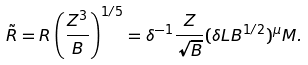Convert formula to latex. <formula><loc_0><loc_0><loc_500><loc_500>\tilde { R } = R \left ( \frac { Z ^ { 3 } } { B } \right ) ^ { 1 / 5 } = \delta ^ { - 1 } \frac { Z } { \sqrt { B } } ( \delta L B ^ { 1 / 2 } ) ^ { \mu } M .</formula> 